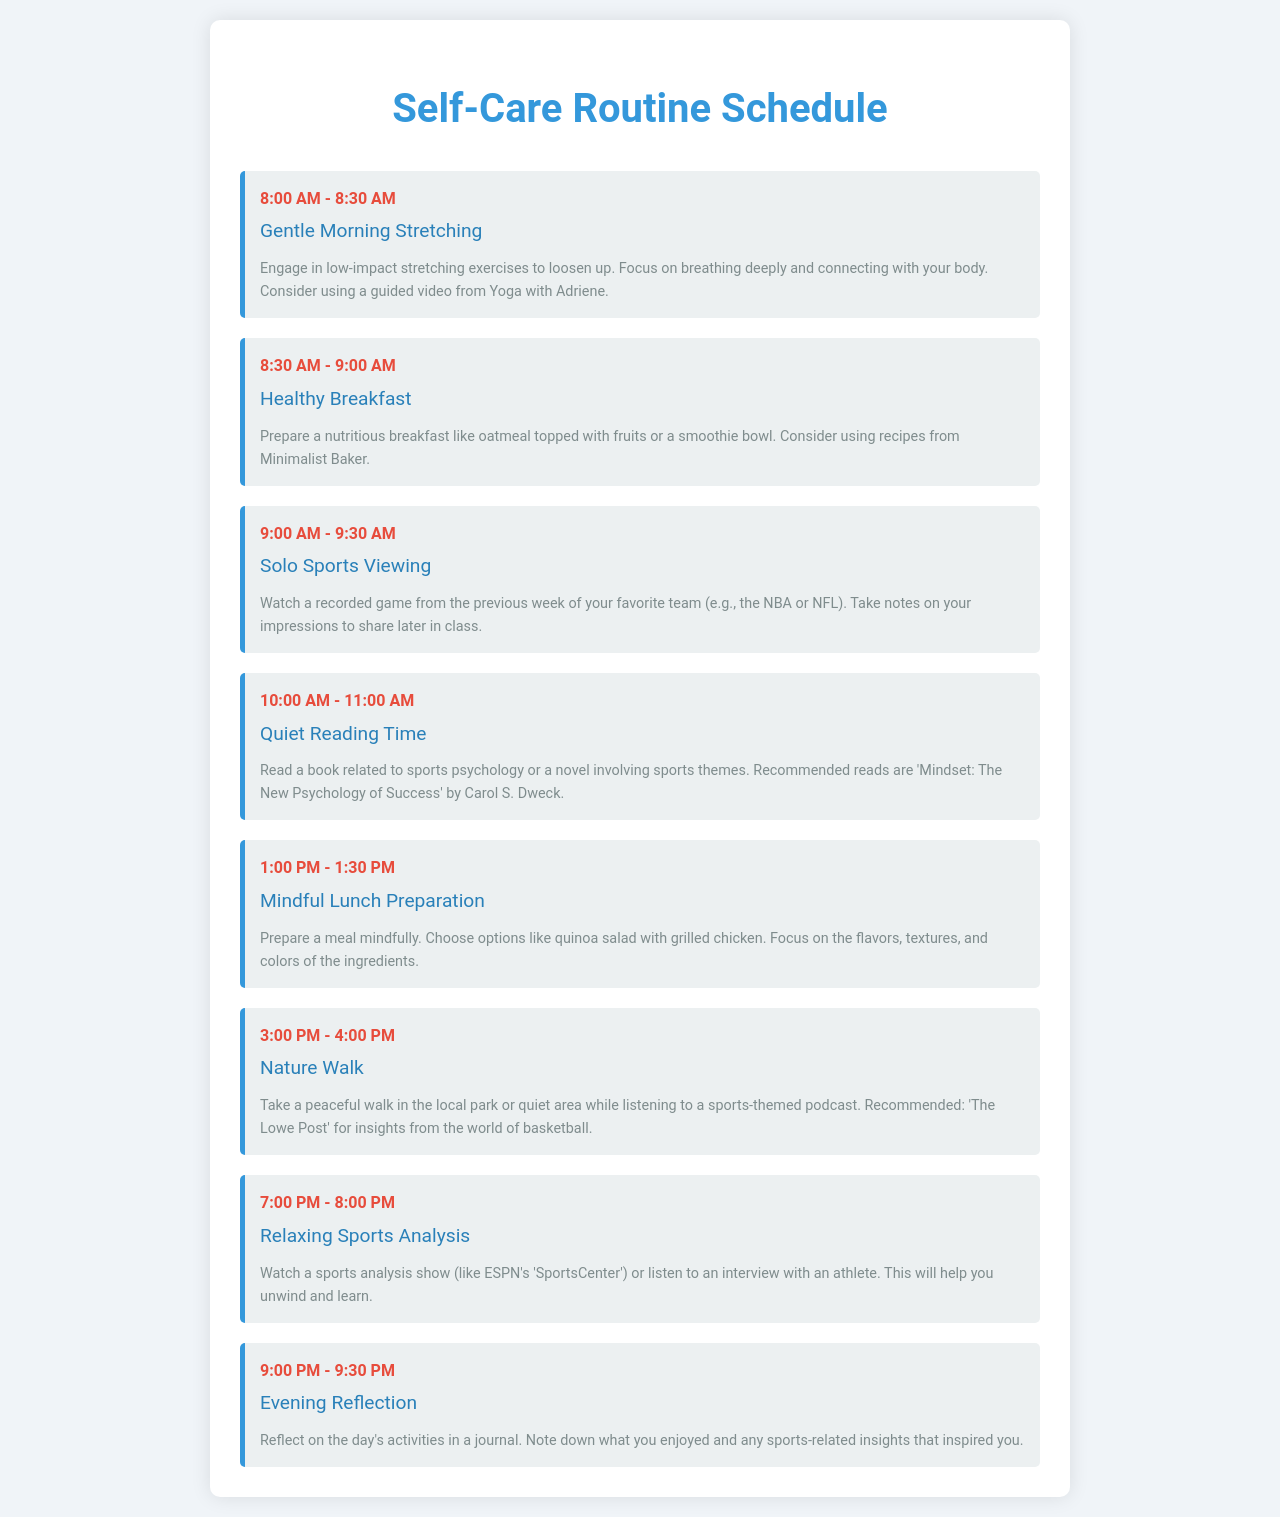What activity is scheduled at 8:00 AM? The activity scheduled at 8:00 AM is "Gentle Morning Stretching."
Answer: Gentle Morning Stretching What time does the "Solo Sports Viewing" take place? "Solo Sports Viewing" takes place from 9:00 AM to 9:30 AM.
Answer: 9:00 AM - 9:30 AM Which book is recommended for Quiet Reading Time? The recommended book for Quiet Reading Time is "Mindset: The New Psychology of Success" by Carol S. Dweck.
Answer: Mindset: The New Psychology of Success How long is the "Mindful Lunch Preparation" activity? "Mindful Lunch Preparation" lasts for 30 minutes.
Answer: 30 minutes What type of podcast is recommended during the Nature Walk? A sports-themed podcast is recommended during the Nature Walk.
Answer: sports-themed podcast What is the main focus of the evening activity? The main focus of the evening activity is to reflect on the day's activities.
Answer: reflect on the day's activities What color is used for the headings in the schedule? The color used for the headings is blue.
Answer: blue Which sports analysis show is suggested for relaxation? The suggested sports analysis show is ESPN's "SportsCenter."
Answer: ESPN's SportsCenter 